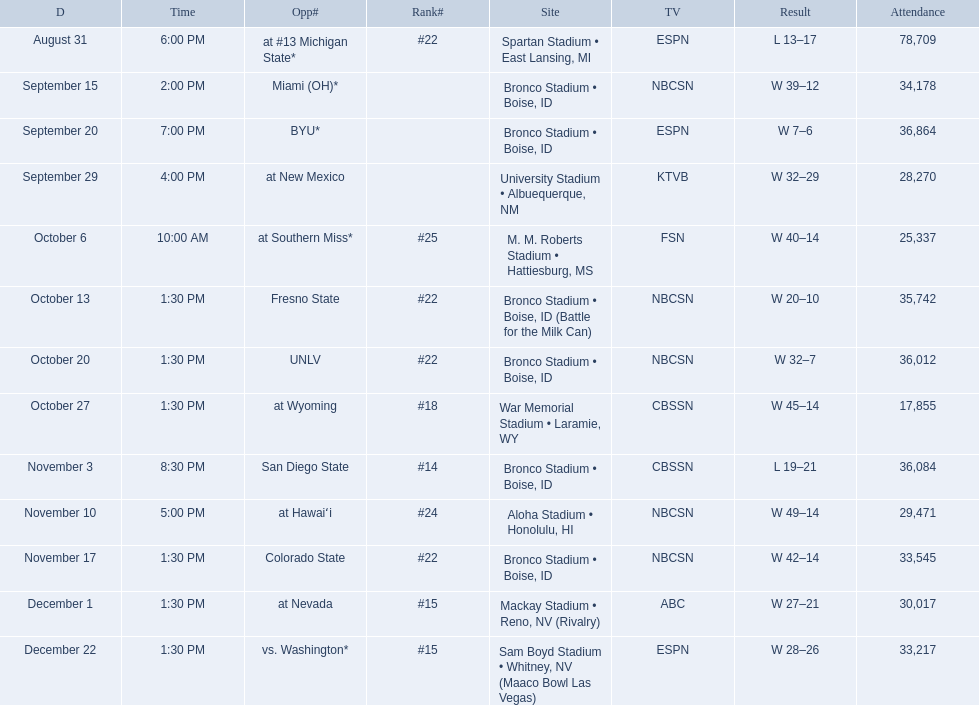What are the opponent teams of the 2012 boise state broncos football team? At #13 michigan state*, miami (oh)*, byu*, at new mexico, at southern miss*, fresno state, unlv, at wyoming, san diego state, at hawaiʻi, colorado state, at nevada, vs. washington*. How has the highest rank of these opponents? San Diego State. 